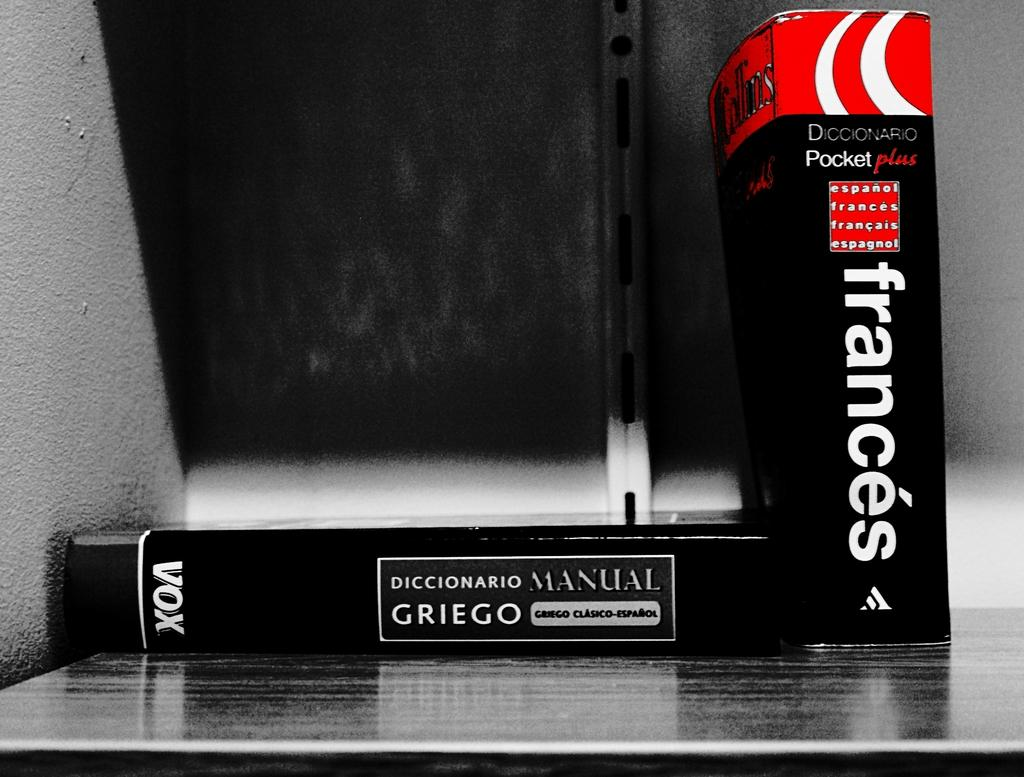<image>
Provide a brief description of the given image. A couple of books including one called Frances. 